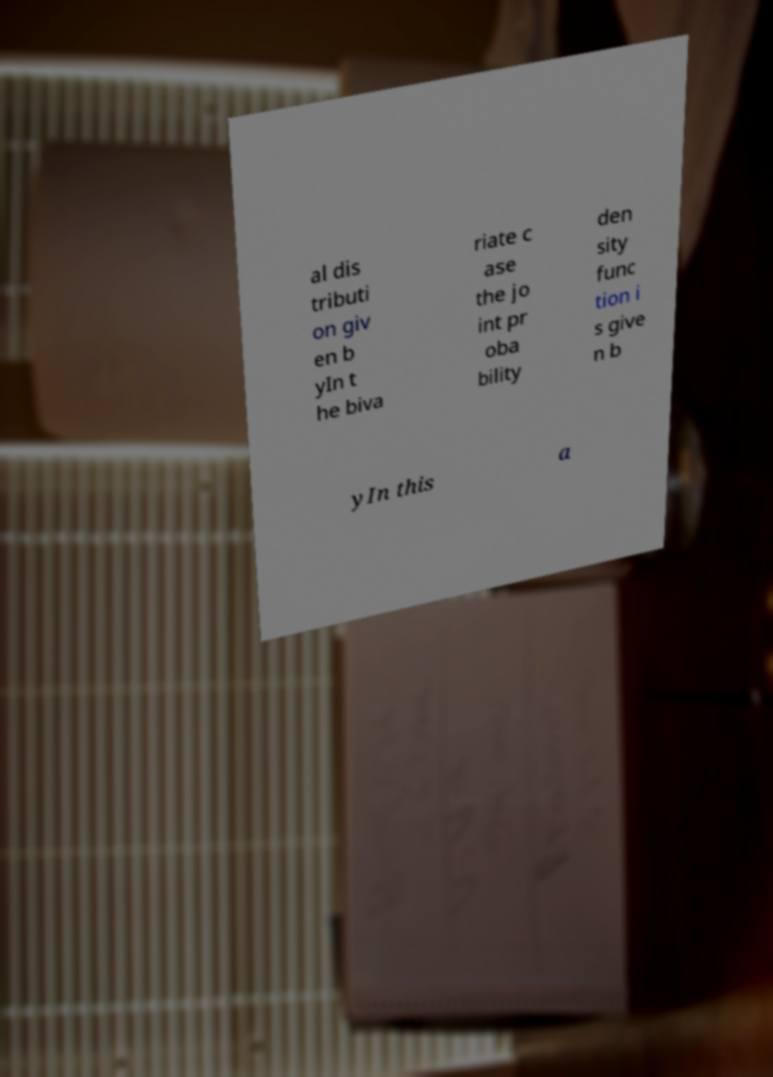What messages or text are displayed in this image? I need them in a readable, typed format. al dis tributi on giv en b yIn t he biva riate c ase the jo int pr oba bility den sity func tion i s give n b yIn this a 